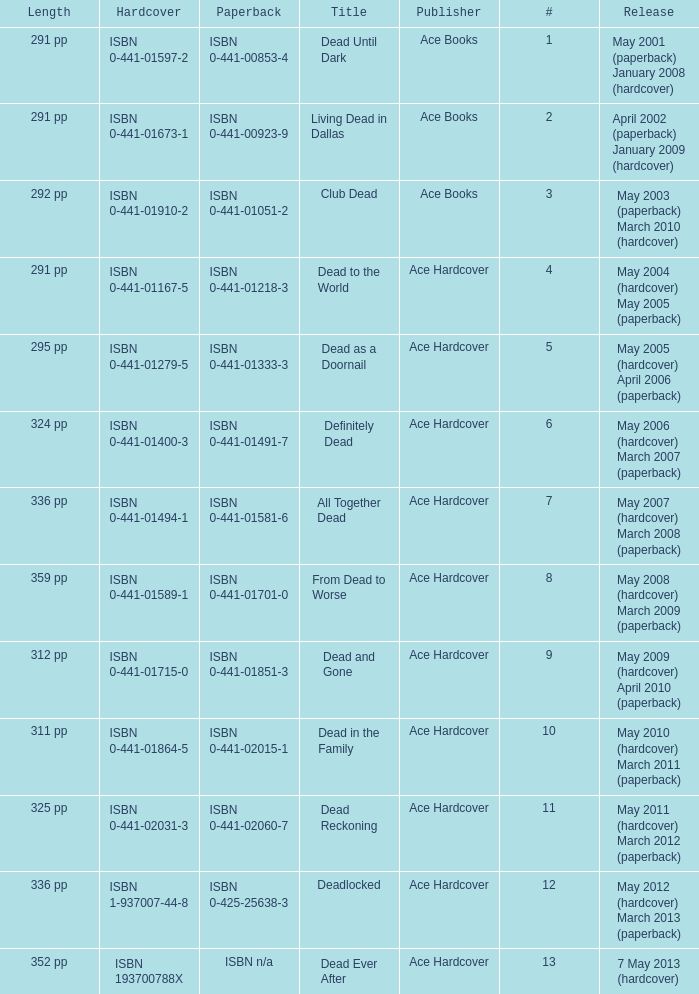Who pubilshed isbn 1-937007-44-8? Ace Hardcover. 